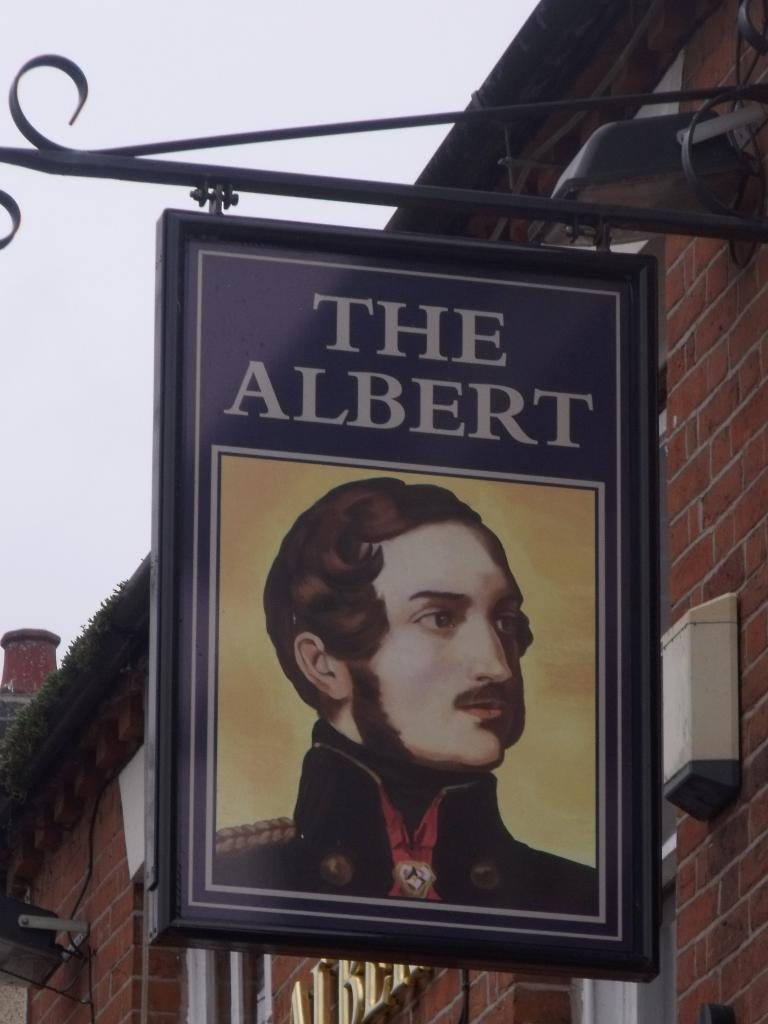What is the main subject in the center of the image? There is a poster in the center of the image. What can be read on the poster? The poster has the text "the albert" written on it. Can you see any veins in the poster? There are no veins present in the poster; it is a text-based image with the words "the albert." 